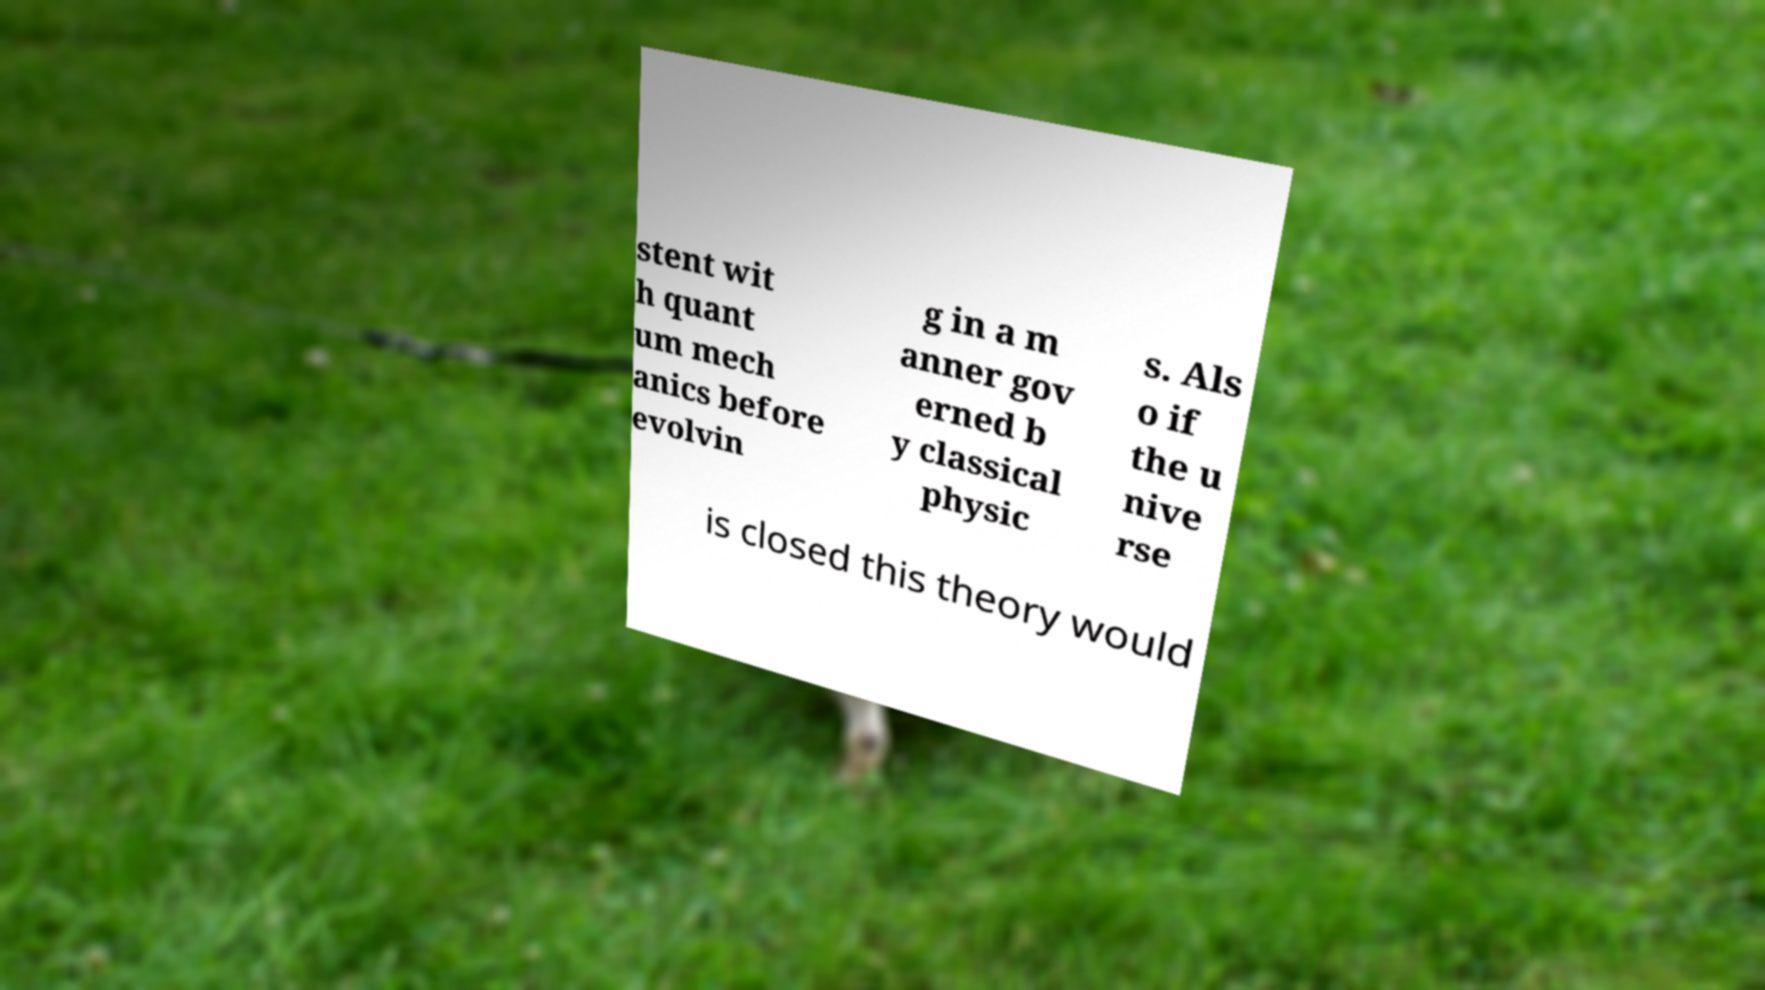Could you assist in decoding the text presented in this image and type it out clearly? stent wit h quant um mech anics before evolvin g in a m anner gov erned b y classical physic s. Als o if the u nive rse is closed this theory would 